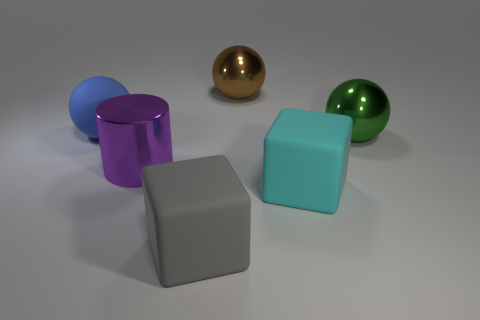Subtract all blue spheres. How many spheres are left? 2 Subtract all gray cubes. How many cubes are left? 1 Add 3 brown shiny objects. How many objects exist? 9 Subtract all cylinders. How many objects are left? 5 Subtract all brown blocks. Subtract all red balls. How many blocks are left? 2 Subtract all small blue cylinders. Subtract all large gray blocks. How many objects are left? 5 Add 3 big green metallic spheres. How many big green metallic spheres are left? 4 Add 4 large purple shiny objects. How many large purple shiny objects exist? 5 Subtract 0 cyan cylinders. How many objects are left? 6 